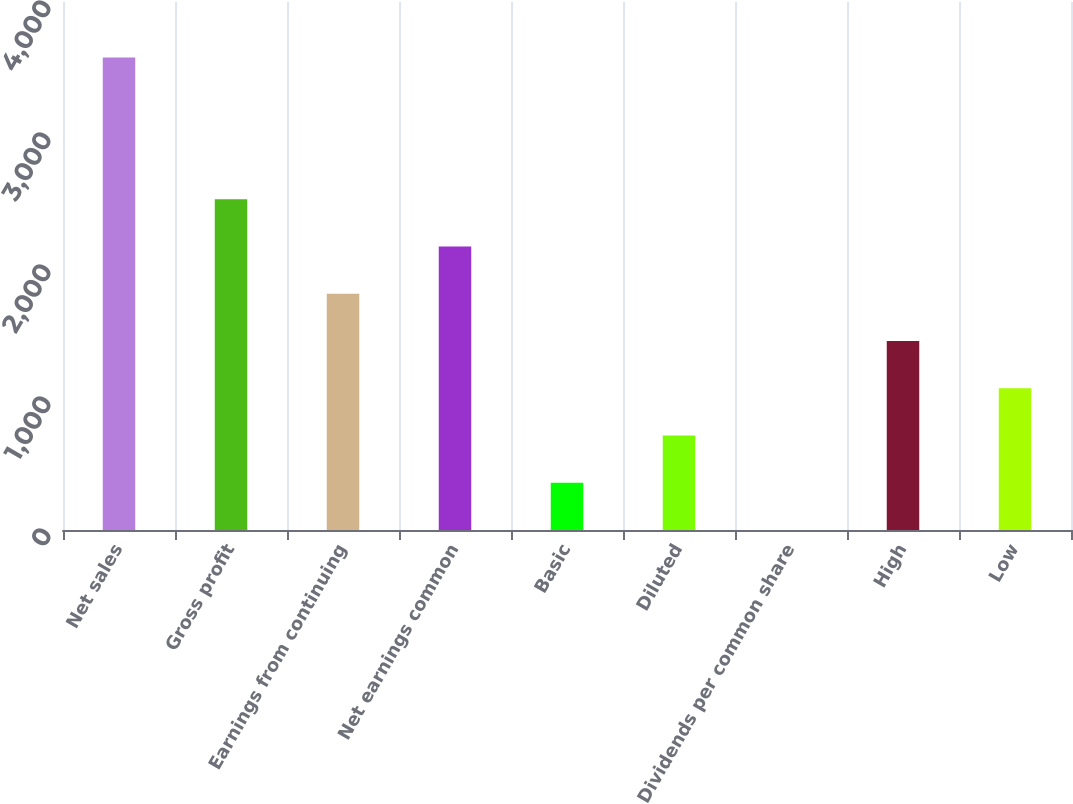Convert chart. <chart><loc_0><loc_0><loc_500><loc_500><bar_chart><fcel>Net sales<fcel>Gross profit<fcel>Earnings from continuing<fcel>Net earnings common<fcel>Basic<fcel>Diluted<fcel>Dividends per common share<fcel>High<fcel>Low<nl><fcel>3579<fcel>2505.42<fcel>1789.72<fcel>2147.57<fcel>358.32<fcel>716.17<fcel>0.47<fcel>1431.87<fcel>1074.02<nl></chart> 